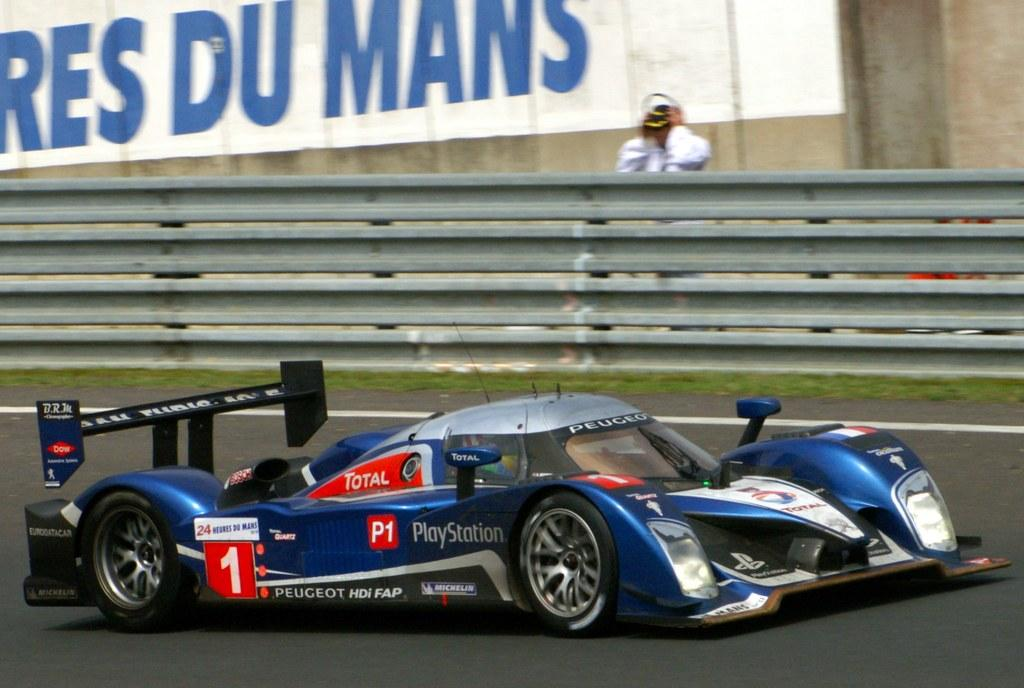What is the main subject of the image? There is a vehicle on a road in the image. Can you describe the road in the image? The road has a white color line. What can be seen in the background of the image? There is grass, a fence, a person, and a painting on a wall in the background of the image. Is the person in the background of the image crying? There is no indication in the image that the person is crying. What type of plastic object can be seen in the image? There is no plastic object present in the image. 